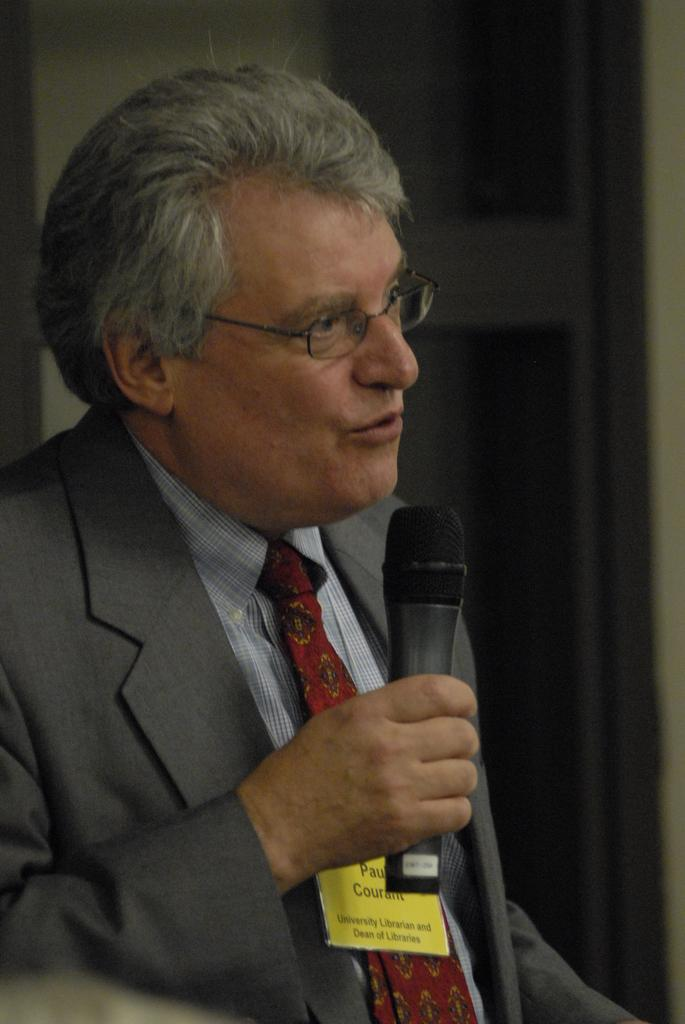What is the main subject of the image? There is a person in the image. What is the person holding in the image? The person is holding a mic. What time of day is it in the image? The time of day cannot be determined from the image, as there are no clues or context provided. 